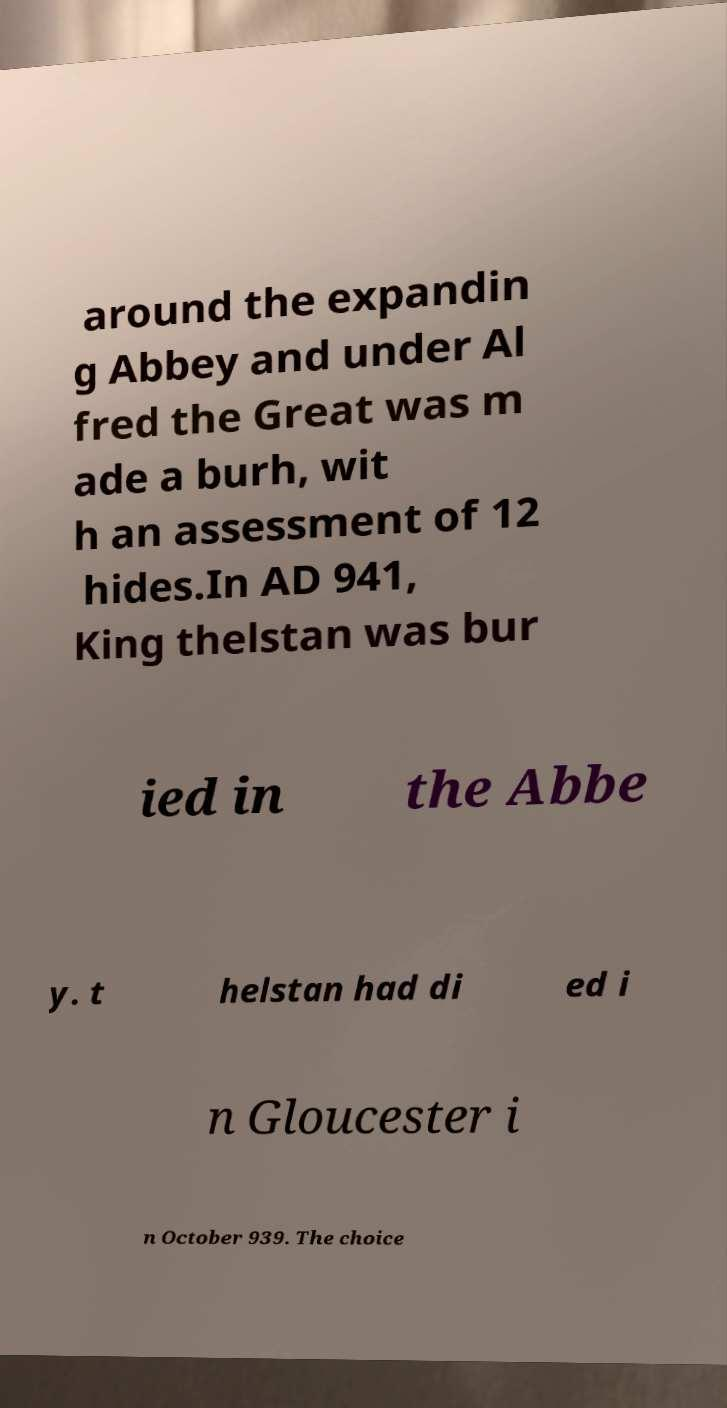Please read and relay the text visible in this image. What does it say? around the expandin g Abbey and under Al fred the Great was m ade a burh, wit h an assessment of 12 hides.In AD 941, King thelstan was bur ied in the Abbe y. t helstan had di ed i n Gloucester i n October 939. The choice 